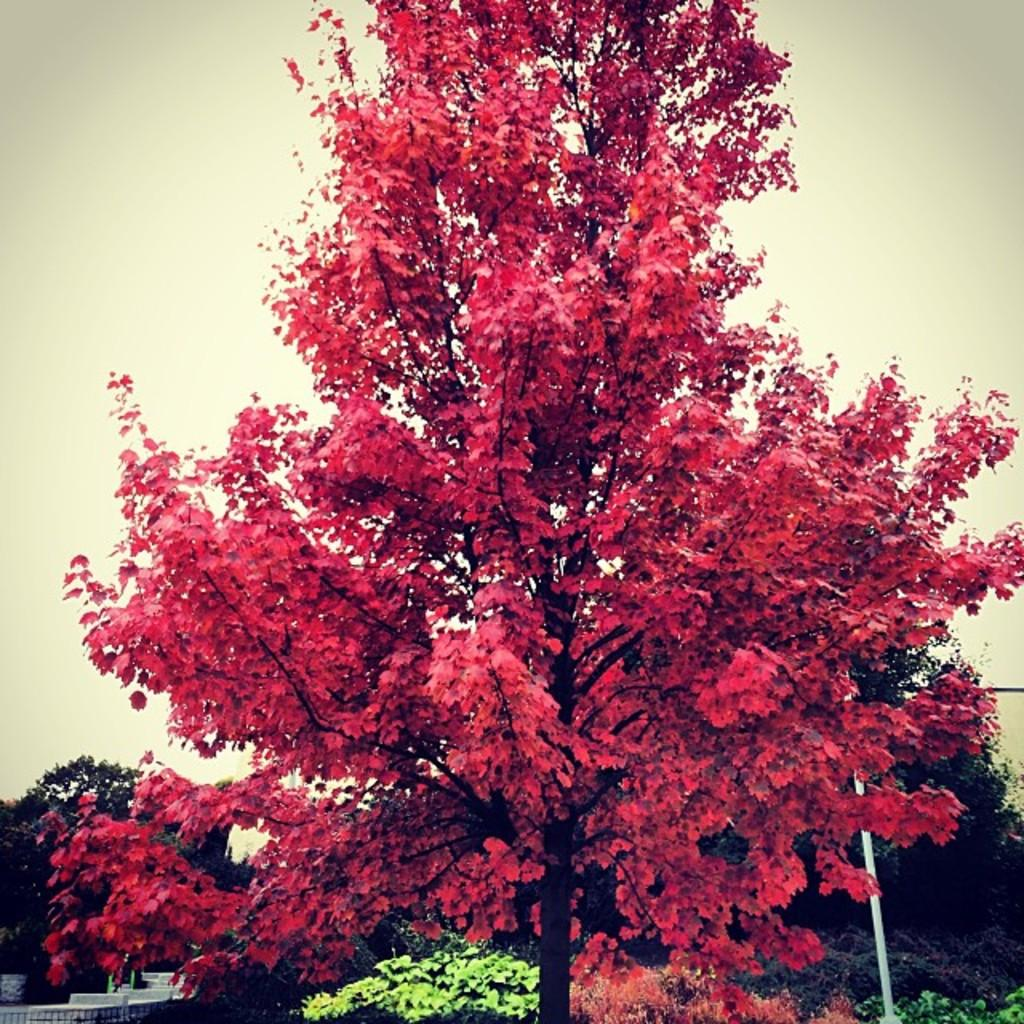What type of natural elements can be seen in the image? There are trees and plants in the image. What type of man-made structures are visible in the image? There are buildings in the image. What part of the natural environment is visible in the image? The sky is visible in the image. What type of bag is hanging from the tree in the image? There is no bag hanging from the tree in the image; only trees, plants, buildings, and the sky are present. 